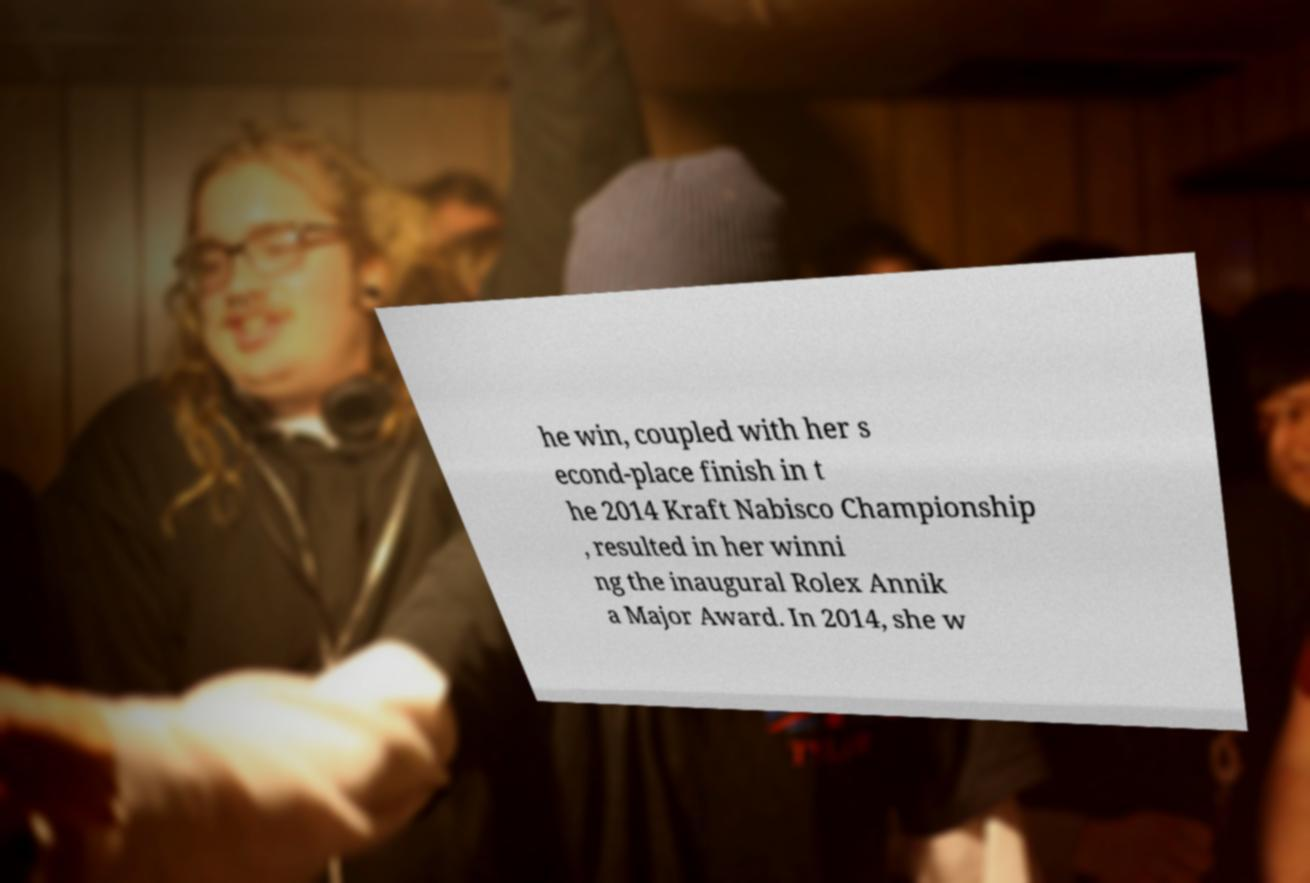There's text embedded in this image that I need extracted. Can you transcribe it verbatim? he win, coupled with her s econd-place finish in t he 2014 Kraft Nabisco Championship , resulted in her winni ng the inaugural Rolex Annik a Major Award. In 2014, she w 